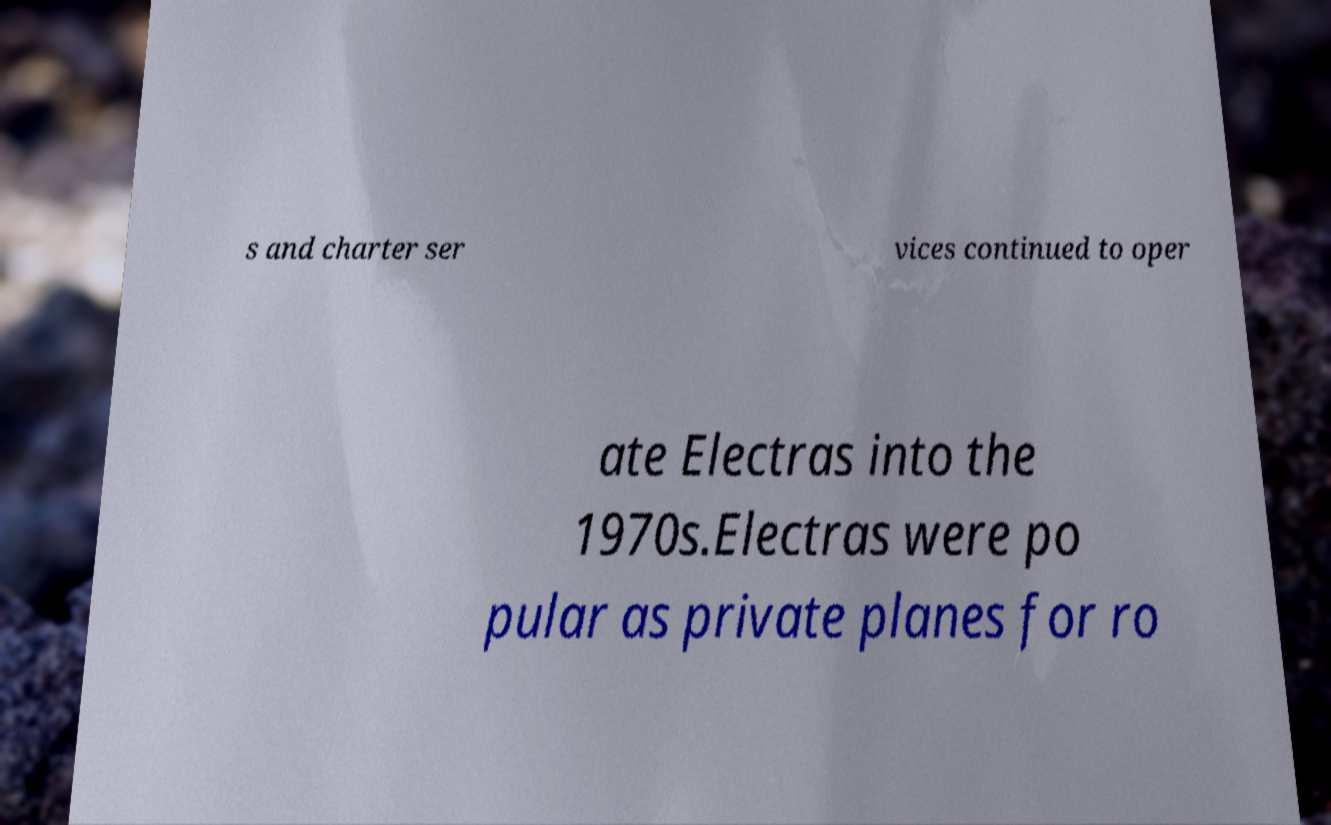Can you read and provide the text displayed in the image?This photo seems to have some interesting text. Can you extract and type it out for me? s and charter ser vices continued to oper ate Electras into the 1970s.Electras were po pular as private planes for ro 